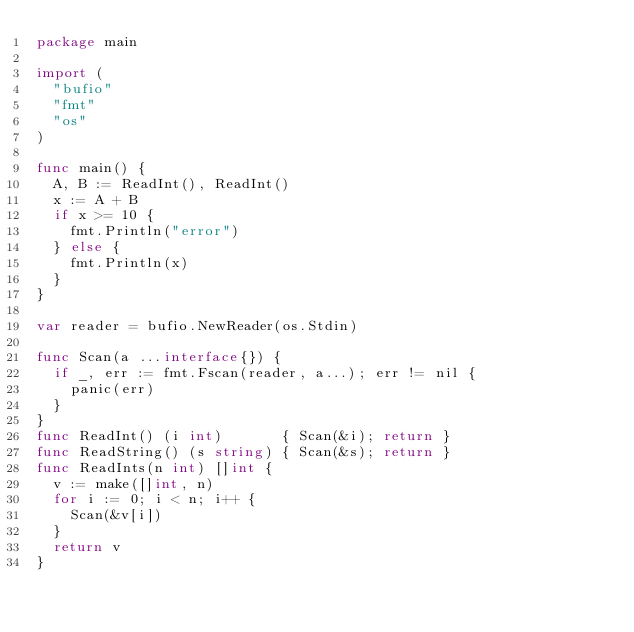<code> <loc_0><loc_0><loc_500><loc_500><_Go_>package main

import (
	"bufio"
	"fmt"
	"os"
)

func main() {
	A, B := ReadInt(), ReadInt()
	x := A + B
	if x >= 10 {
		fmt.Println("error")
	} else {
		fmt.Println(x)
	}
}

var reader = bufio.NewReader(os.Stdin)

func Scan(a ...interface{}) {
	if _, err := fmt.Fscan(reader, a...); err != nil {
		panic(err)
	}
}
func ReadInt() (i int)       { Scan(&i); return }
func ReadString() (s string) { Scan(&s); return }
func ReadInts(n int) []int {
	v := make([]int, n)
	for i := 0; i < n; i++ {
		Scan(&v[i])
	}
	return v
}
</code> 